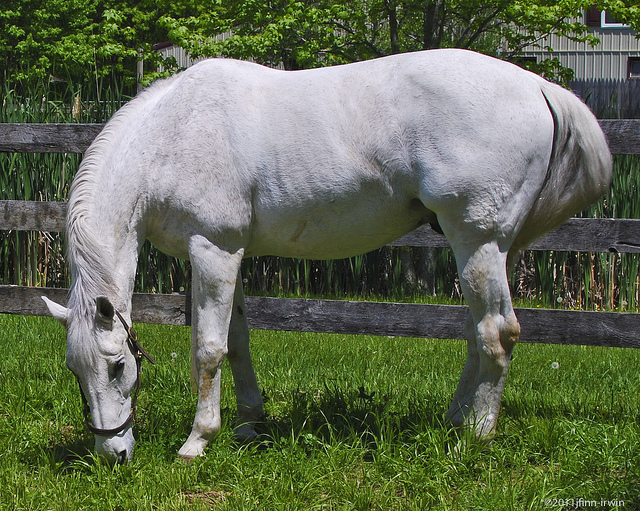Can you explain the significance of horses grazing? Certainly! Grazing is a fundamental behavior for horses, reflecting their natural instincts. In the wild, horses spend a significant portion of their day eating grass, which provides essential nutrients and keeps their digestive system functioning smoothly. Grazing also engages a horse's mind, reducing stress and promoting well-being. For domestic horses, grazing mimics their natural dietary habits and environmental conditions, contributing to their overall health and happiness. 